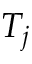<formula> <loc_0><loc_0><loc_500><loc_500>T _ { j }</formula> 